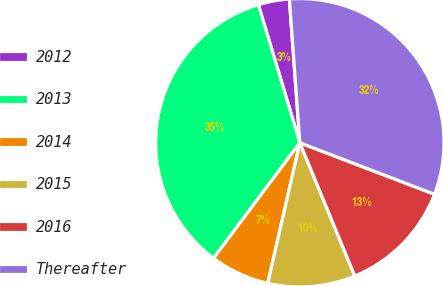Convert chart to OTSL. <chart><loc_0><loc_0><loc_500><loc_500><pie_chart><fcel>2012<fcel>2013<fcel>2014<fcel>2015<fcel>2016<fcel>Thereafter<nl><fcel>3.49%<fcel>35.14%<fcel>6.64%<fcel>9.8%<fcel>12.96%<fcel>31.98%<nl></chart> 